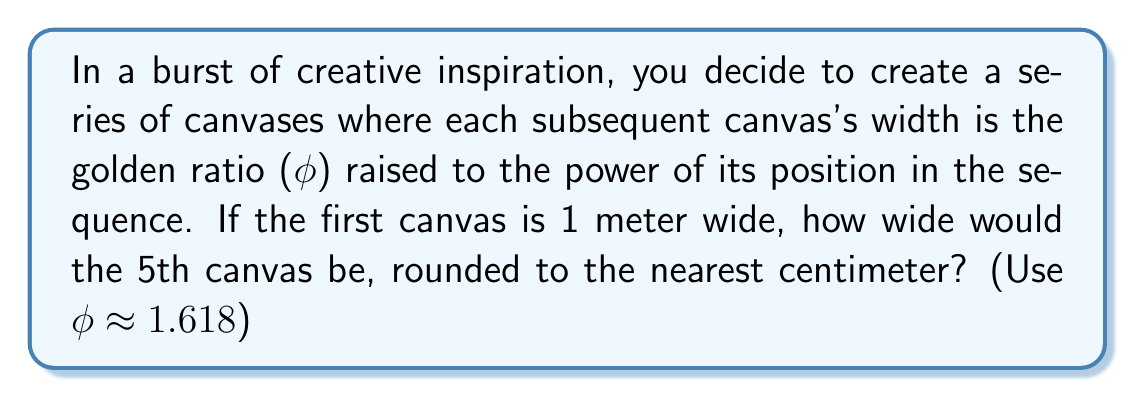Could you help me with this problem? Let's approach this step-by-step, embracing the beauty of the golden ratio in our artistic journey:

1) The golden ratio, $\phi$, is approximately 1.618.

2) The width of each canvas follows the pattern:
   Canvas 1: $1 \times \phi^0 = 1$ meter
   Canvas 2: $1 \times \phi^1 = \phi$ meters
   Canvas 3: $1 \times \phi^2$ meters
   Canvas 4: $1 \times \phi^3$ meters
   Canvas 5: $1 \times \phi^4$ meters

3) We need to calculate $\phi^4$:
   $$\phi^4 \approx 1.618^4$$

4) Let's calculate this step-by-step:
   $1.618^2 \approx 2.618$
   $2.618 \times 1.618 \approx 4.236$
   $4.236 \times 1.618 \approx 6.854$

5) So, the 5th canvas would be approximately 6.854 meters wide.

6) Converting to centimeters:
   $6.854 \times 100 = 685.4$ cm

7) Rounding to the nearest centimeter:
   685.4 cm rounds to 685 cm
Answer: 685 cm 